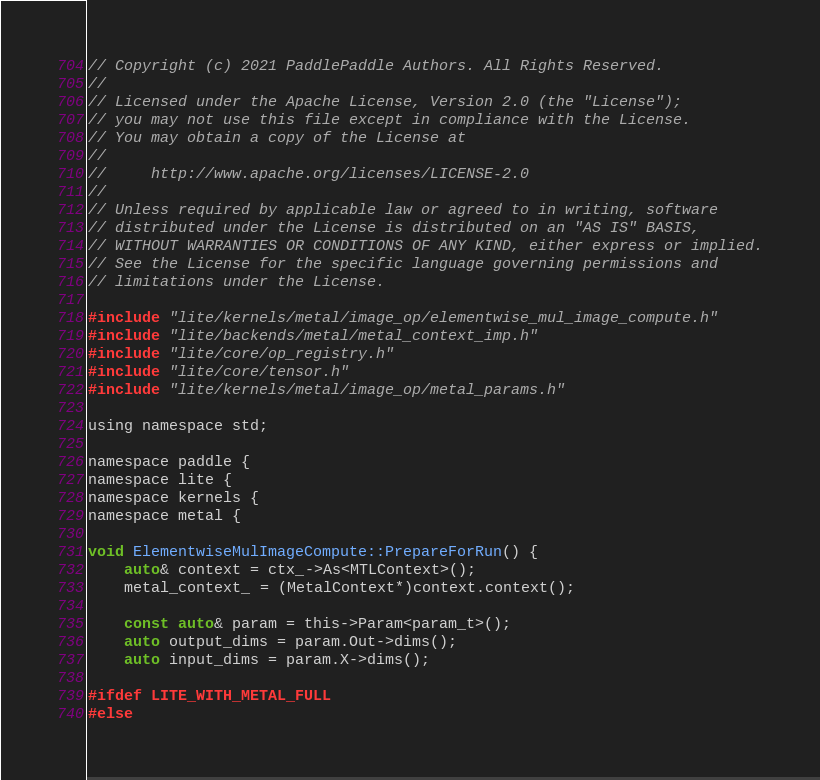<code> <loc_0><loc_0><loc_500><loc_500><_ObjectiveC_>// Copyright (c) 2021 PaddlePaddle Authors. All Rights Reserved.
//
// Licensed under the Apache License, Version 2.0 (the "License");
// you may not use this file except in compliance with the License.
// You may obtain a copy of the License at
//
//     http://www.apache.org/licenses/LICENSE-2.0
//
// Unless required by applicable law or agreed to in writing, software
// distributed under the License is distributed on an "AS IS" BASIS,
// WITHOUT WARRANTIES OR CONDITIONS OF ANY KIND, either express or implied.
// See the License for the specific language governing permissions and
// limitations under the License.

#include "lite/kernels/metal/image_op/elementwise_mul_image_compute.h"
#include "lite/backends/metal/metal_context_imp.h"
#include "lite/core/op_registry.h"
#include "lite/core/tensor.h"
#include "lite/kernels/metal/image_op/metal_params.h"

using namespace std;

namespace paddle {
namespace lite {
namespace kernels {
namespace metal {

void ElementwiseMulImageCompute::PrepareForRun() {
    auto& context = ctx_->As<MTLContext>();
    metal_context_ = (MetalContext*)context.context();

    const auto& param = this->Param<param_t>();
    auto output_dims = param.Out->dims();
    auto input_dims = param.X->dims();

#ifdef LITE_WITH_METAL_FULL
#else</code> 